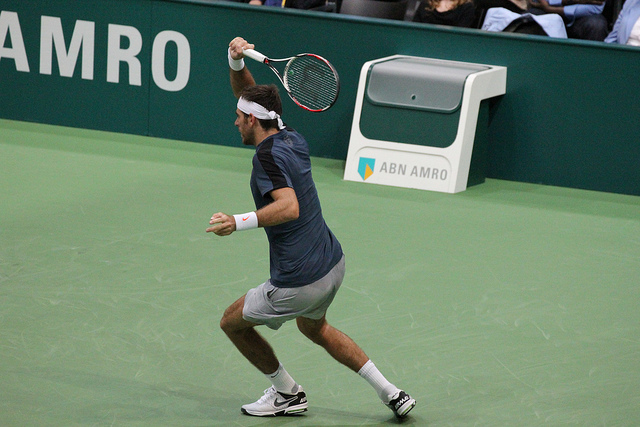What bank is a sponsor of the tennis event?
A. chase
B. wells fargo
C. citibank
D. abn amro
Answer with the option's letter from the given choices directly. D 